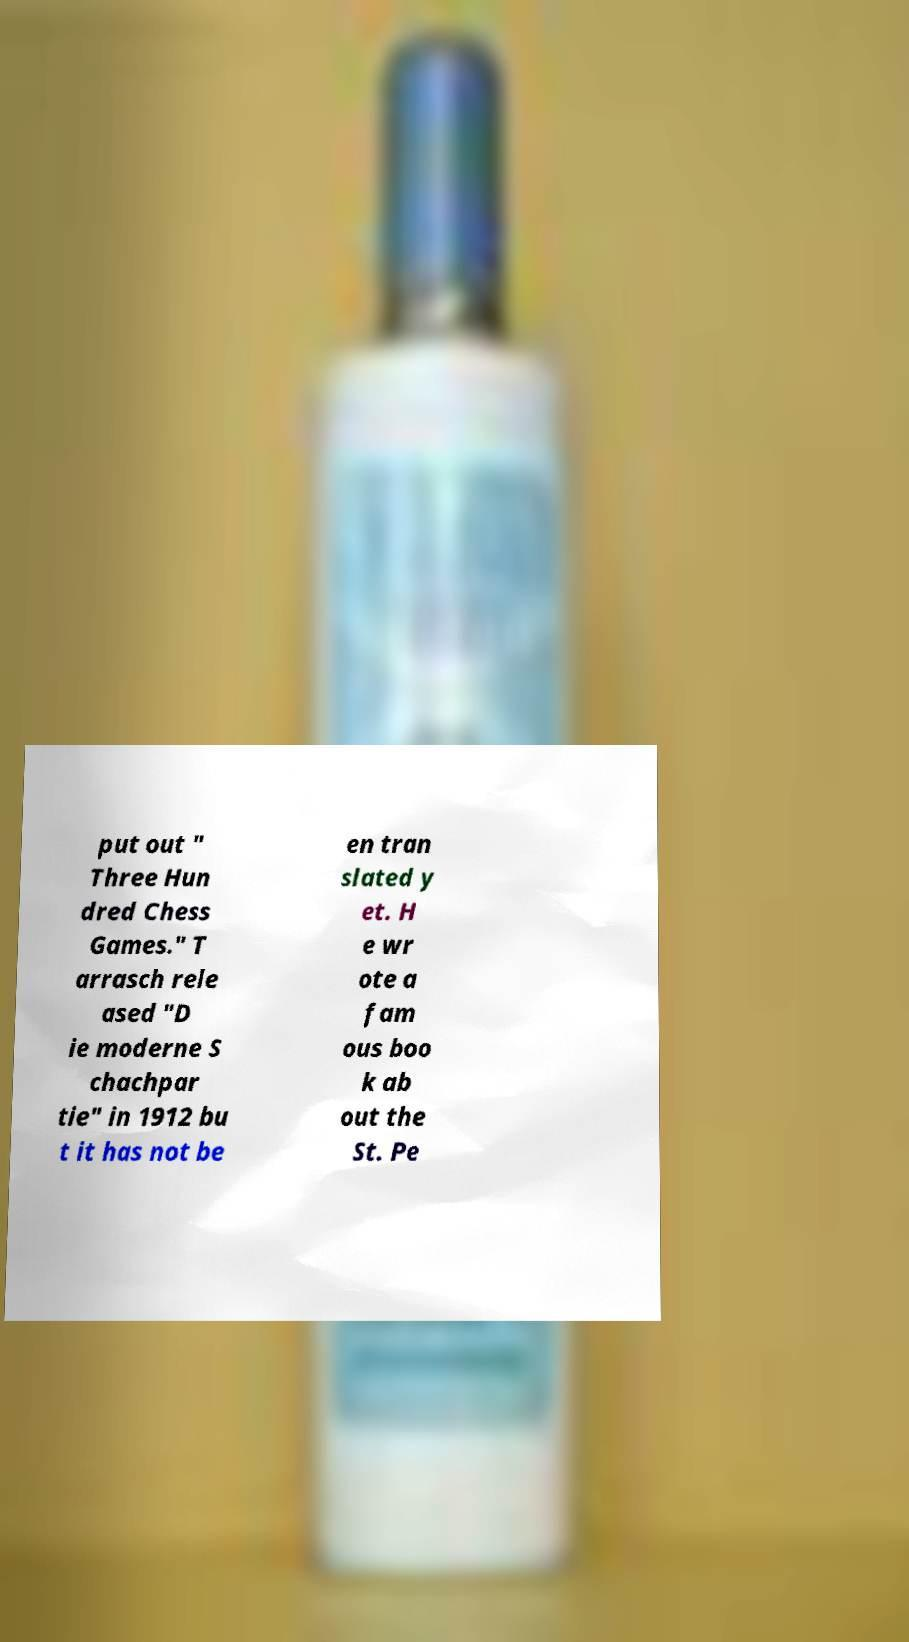For documentation purposes, I need the text within this image transcribed. Could you provide that? put out " Three Hun dred Chess Games." T arrasch rele ased "D ie moderne S chachpar tie" in 1912 bu t it has not be en tran slated y et. H e wr ote a fam ous boo k ab out the St. Pe 